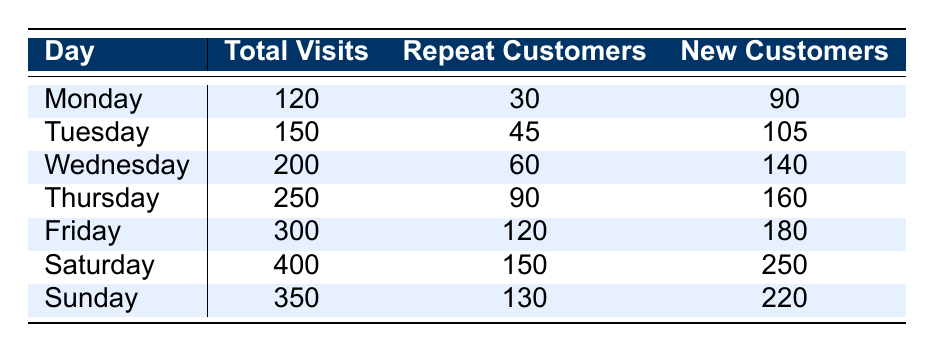What day had the highest total visits? By looking at the Total Visits column in the table, Saturday has the highest value with 400 visits.
Answer: Saturday How many new customers visited on Thursday? From the table, the New Customers column for Thursday shows a value of 160.
Answer: 160 What is the total number of repeat customers across all days? To get the total, we sum the Repeat Customers for each day: 30 + 45 + 60 + 90 + 120 + 150 + 130 = 625.
Answer: 625 Which day had the lowest number of new customers? By examining the New Customers column, we see that Monday had the lowest number of new customers with a count of 90.
Answer: Monday True or False: Sunday had more repeat customers than Wednesday. Checking the Repeat Customers for Sunday (130) and Wednesday (60) shows that Sunday does have more repeat customers than Wednesday.
Answer: True What is the average total number of visits on weekdays (Monday to Friday)? First, we add the total visits from Monday to Friday: 120 + 150 + 200 + 250 + 300 = 1020. There are 5 weekdays, so the average is 1020/5 = 204.
Answer: 204 What is the difference in total visits between Saturday and Thursday? To find the difference, we subtract Thursday's Total Visits (250) from Saturday's Total Visits (400): 400 - 250 = 150.
Answer: 150 How many new customers did we have on Friday? From the table, the New Customers column for Friday indicates there were 180 new customers.
Answer: 180 